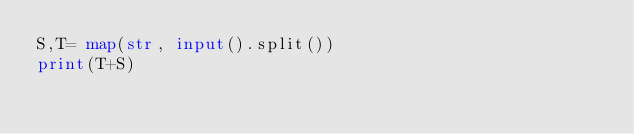Convert code to text. <code><loc_0><loc_0><loc_500><loc_500><_Python_>S,T= map(str, input().split())
print(T+S)</code> 